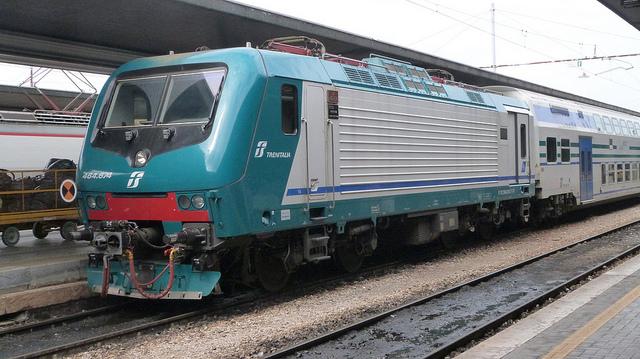How many tracks are there?
Write a very short answer. 2. Is this a passenger train?
Keep it brief. Yes. Are there people on the train?
Short answer required. Yes. Which railroad owns these?
Quick response, please. Amtrak. 